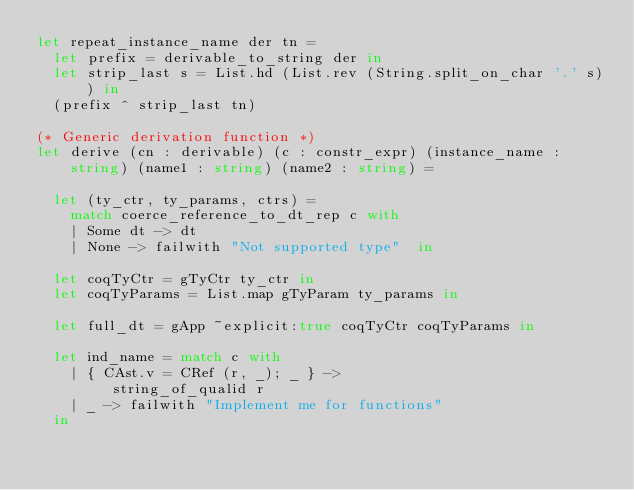<code> <loc_0><loc_0><loc_500><loc_500><_OCaml_>let repeat_instance_name der tn = 
  let prefix = derivable_to_string der in
  let strip_last s = List.hd (List.rev (String.split_on_char '.' s)) in
  (prefix ^ strip_last tn)

(* Generic derivation function *)
let derive (cn : derivable) (c : constr_expr) (instance_name : string) (name1 : string) (name2 : string) =

  let (ty_ctr, ty_params, ctrs) =
    match coerce_reference_to_dt_rep c with
    | Some dt -> dt
    | None -> failwith "Not supported type"  in

  let coqTyCtr = gTyCtr ty_ctr in
  let coqTyParams = List.map gTyParam ty_params in

  let full_dt = gApp ~explicit:true coqTyCtr coqTyParams in

  let ind_name = match c with
    | { CAst.v = CRef (r, _); _ } ->
         string_of_qualid r
    | _ -> failwith "Implement me for functions" 
  in
</code> 